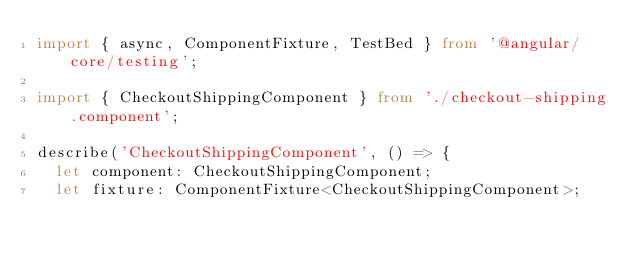<code> <loc_0><loc_0><loc_500><loc_500><_TypeScript_>import { async, ComponentFixture, TestBed } from '@angular/core/testing';

import { CheckoutShippingComponent } from './checkout-shipping.component';

describe('CheckoutShippingComponent', () => {
  let component: CheckoutShippingComponent;
  let fixture: ComponentFixture<CheckoutShippingComponent>;
</code> 